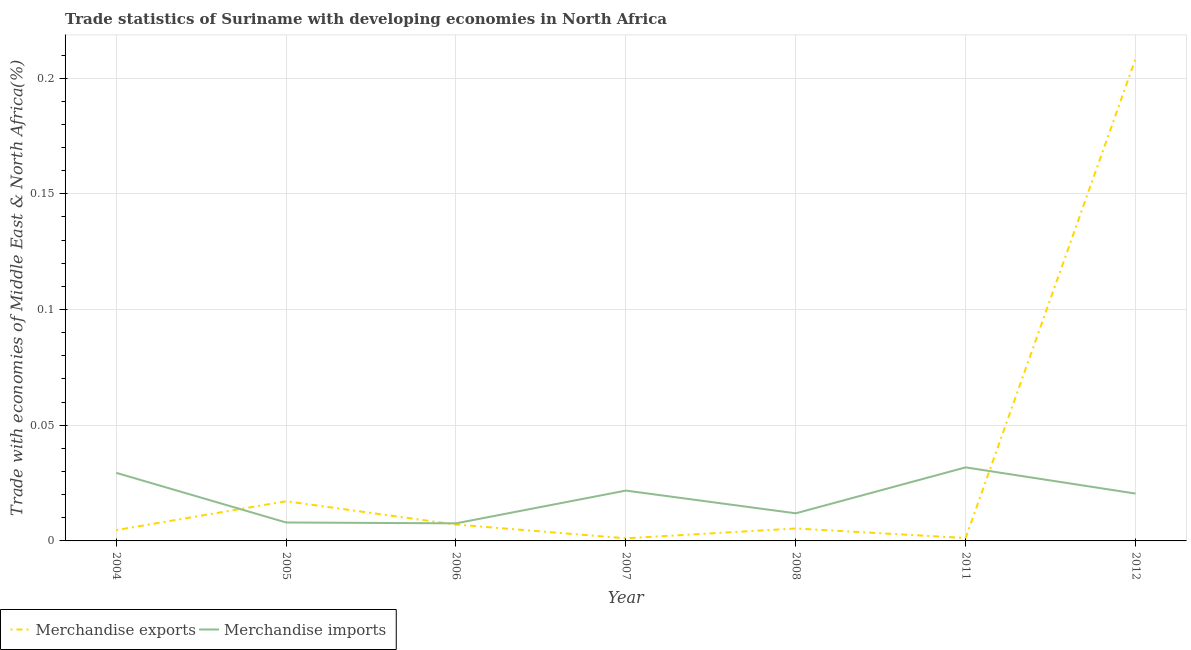How many different coloured lines are there?
Your answer should be compact. 2. Does the line corresponding to merchandise exports intersect with the line corresponding to merchandise imports?
Ensure brevity in your answer.  Yes. Is the number of lines equal to the number of legend labels?
Give a very brief answer. Yes. What is the merchandise imports in 2008?
Your answer should be very brief. 0.01. Across all years, what is the maximum merchandise imports?
Make the answer very short. 0.03. Across all years, what is the minimum merchandise exports?
Keep it short and to the point. 0. In which year was the merchandise imports minimum?
Provide a short and direct response. 2006. What is the total merchandise imports in the graph?
Your answer should be very brief. 0.13. What is the difference between the merchandise exports in 2004 and that in 2007?
Your answer should be very brief. 0. What is the difference between the merchandise imports in 2011 and the merchandise exports in 2008?
Your answer should be compact. 0.03. What is the average merchandise exports per year?
Provide a short and direct response. 0.04. In the year 2004, what is the difference between the merchandise exports and merchandise imports?
Provide a succinct answer. -0.02. What is the ratio of the merchandise exports in 2005 to that in 2008?
Your answer should be compact. 3.19. What is the difference between the highest and the second highest merchandise exports?
Give a very brief answer. 0.19. What is the difference between the highest and the lowest merchandise imports?
Provide a succinct answer. 0.02. Is the sum of the merchandise exports in 2005 and 2012 greater than the maximum merchandise imports across all years?
Offer a very short reply. Yes. Does the merchandise imports monotonically increase over the years?
Give a very brief answer. No. Is the merchandise imports strictly greater than the merchandise exports over the years?
Offer a very short reply. No. Is the merchandise imports strictly less than the merchandise exports over the years?
Give a very brief answer. No. How many lines are there?
Make the answer very short. 2. Are the values on the major ticks of Y-axis written in scientific E-notation?
Make the answer very short. No. Does the graph contain any zero values?
Your response must be concise. No. Where does the legend appear in the graph?
Give a very brief answer. Bottom left. What is the title of the graph?
Provide a short and direct response. Trade statistics of Suriname with developing economies in North Africa. Does "Long-term debt" appear as one of the legend labels in the graph?
Ensure brevity in your answer.  No. What is the label or title of the Y-axis?
Ensure brevity in your answer.  Trade with economies of Middle East & North Africa(%). What is the Trade with economies of Middle East & North Africa(%) of Merchandise exports in 2004?
Give a very brief answer. 0. What is the Trade with economies of Middle East & North Africa(%) in Merchandise imports in 2004?
Your answer should be very brief. 0.03. What is the Trade with economies of Middle East & North Africa(%) in Merchandise exports in 2005?
Offer a very short reply. 0.02. What is the Trade with economies of Middle East & North Africa(%) in Merchandise imports in 2005?
Your answer should be very brief. 0.01. What is the Trade with economies of Middle East & North Africa(%) in Merchandise exports in 2006?
Your answer should be very brief. 0.01. What is the Trade with economies of Middle East & North Africa(%) in Merchandise imports in 2006?
Give a very brief answer. 0.01. What is the Trade with economies of Middle East & North Africa(%) of Merchandise exports in 2007?
Your answer should be compact. 0. What is the Trade with economies of Middle East & North Africa(%) of Merchandise imports in 2007?
Your answer should be very brief. 0.02. What is the Trade with economies of Middle East & North Africa(%) in Merchandise exports in 2008?
Offer a terse response. 0.01. What is the Trade with economies of Middle East & North Africa(%) of Merchandise imports in 2008?
Your answer should be compact. 0.01. What is the Trade with economies of Middle East & North Africa(%) in Merchandise exports in 2011?
Keep it short and to the point. 0. What is the Trade with economies of Middle East & North Africa(%) of Merchandise imports in 2011?
Ensure brevity in your answer.  0.03. What is the Trade with economies of Middle East & North Africa(%) of Merchandise exports in 2012?
Your response must be concise. 0.21. What is the Trade with economies of Middle East & North Africa(%) in Merchandise imports in 2012?
Make the answer very short. 0.02. Across all years, what is the maximum Trade with economies of Middle East & North Africa(%) in Merchandise exports?
Offer a very short reply. 0.21. Across all years, what is the maximum Trade with economies of Middle East & North Africa(%) in Merchandise imports?
Give a very brief answer. 0.03. Across all years, what is the minimum Trade with economies of Middle East & North Africa(%) in Merchandise exports?
Give a very brief answer. 0. Across all years, what is the minimum Trade with economies of Middle East & North Africa(%) in Merchandise imports?
Your response must be concise. 0.01. What is the total Trade with economies of Middle East & North Africa(%) of Merchandise exports in the graph?
Your answer should be very brief. 0.24. What is the total Trade with economies of Middle East & North Africa(%) in Merchandise imports in the graph?
Your answer should be very brief. 0.13. What is the difference between the Trade with economies of Middle East & North Africa(%) in Merchandise exports in 2004 and that in 2005?
Offer a very short reply. -0.01. What is the difference between the Trade with economies of Middle East & North Africa(%) of Merchandise imports in 2004 and that in 2005?
Your response must be concise. 0.02. What is the difference between the Trade with economies of Middle East & North Africa(%) in Merchandise exports in 2004 and that in 2006?
Your answer should be very brief. -0. What is the difference between the Trade with economies of Middle East & North Africa(%) in Merchandise imports in 2004 and that in 2006?
Offer a very short reply. 0.02. What is the difference between the Trade with economies of Middle East & North Africa(%) of Merchandise exports in 2004 and that in 2007?
Your response must be concise. 0. What is the difference between the Trade with economies of Middle East & North Africa(%) in Merchandise imports in 2004 and that in 2007?
Ensure brevity in your answer.  0.01. What is the difference between the Trade with economies of Middle East & North Africa(%) in Merchandise exports in 2004 and that in 2008?
Give a very brief answer. -0. What is the difference between the Trade with economies of Middle East & North Africa(%) in Merchandise imports in 2004 and that in 2008?
Offer a very short reply. 0.02. What is the difference between the Trade with economies of Middle East & North Africa(%) of Merchandise exports in 2004 and that in 2011?
Keep it short and to the point. 0. What is the difference between the Trade with economies of Middle East & North Africa(%) of Merchandise imports in 2004 and that in 2011?
Provide a succinct answer. -0. What is the difference between the Trade with economies of Middle East & North Africa(%) of Merchandise exports in 2004 and that in 2012?
Ensure brevity in your answer.  -0.2. What is the difference between the Trade with economies of Middle East & North Africa(%) of Merchandise imports in 2004 and that in 2012?
Offer a very short reply. 0.01. What is the difference between the Trade with economies of Middle East & North Africa(%) of Merchandise exports in 2005 and that in 2006?
Your response must be concise. 0.01. What is the difference between the Trade with economies of Middle East & North Africa(%) of Merchandise exports in 2005 and that in 2007?
Provide a succinct answer. 0.02. What is the difference between the Trade with economies of Middle East & North Africa(%) in Merchandise imports in 2005 and that in 2007?
Provide a succinct answer. -0.01. What is the difference between the Trade with economies of Middle East & North Africa(%) in Merchandise exports in 2005 and that in 2008?
Offer a very short reply. 0.01. What is the difference between the Trade with economies of Middle East & North Africa(%) in Merchandise imports in 2005 and that in 2008?
Give a very brief answer. -0. What is the difference between the Trade with economies of Middle East & North Africa(%) in Merchandise exports in 2005 and that in 2011?
Your response must be concise. 0.02. What is the difference between the Trade with economies of Middle East & North Africa(%) of Merchandise imports in 2005 and that in 2011?
Keep it short and to the point. -0.02. What is the difference between the Trade with economies of Middle East & North Africa(%) of Merchandise exports in 2005 and that in 2012?
Provide a succinct answer. -0.19. What is the difference between the Trade with economies of Middle East & North Africa(%) in Merchandise imports in 2005 and that in 2012?
Ensure brevity in your answer.  -0.01. What is the difference between the Trade with economies of Middle East & North Africa(%) of Merchandise exports in 2006 and that in 2007?
Ensure brevity in your answer.  0.01. What is the difference between the Trade with economies of Middle East & North Africa(%) in Merchandise imports in 2006 and that in 2007?
Offer a terse response. -0.01. What is the difference between the Trade with economies of Middle East & North Africa(%) in Merchandise exports in 2006 and that in 2008?
Provide a succinct answer. 0. What is the difference between the Trade with economies of Middle East & North Africa(%) in Merchandise imports in 2006 and that in 2008?
Make the answer very short. -0. What is the difference between the Trade with economies of Middle East & North Africa(%) in Merchandise exports in 2006 and that in 2011?
Make the answer very short. 0.01. What is the difference between the Trade with economies of Middle East & North Africa(%) of Merchandise imports in 2006 and that in 2011?
Your answer should be very brief. -0.02. What is the difference between the Trade with economies of Middle East & North Africa(%) in Merchandise exports in 2006 and that in 2012?
Your response must be concise. -0.2. What is the difference between the Trade with economies of Middle East & North Africa(%) in Merchandise imports in 2006 and that in 2012?
Offer a very short reply. -0.01. What is the difference between the Trade with economies of Middle East & North Africa(%) in Merchandise exports in 2007 and that in 2008?
Your answer should be compact. -0. What is the difference between the Trade with economies of Middle East & North Africa(%) in Merchandise imports in 2007 and that in 2008?
Give a very brief answer. 0.01. What is the difference between the Trade with economies of Middle East & North Africa(%) in Merchandise exports in 2007 and that in 2011?
Make the answer very short. -0. What is the difference between the Trade with economies of Middle East & North Africa(%) of Merchandise imports in 2007 and that in 2011?
Make the answer very short. -0.01. What is the difference between the Trade with economies of Middle East & North Africa(%) in Merchandise exports in 2007 and that in 2012?
Your response must be concise. -0.21. What is the difference between the Trade with economies of Middle East & North Africa(%) of Merchandise imports in 2007 and that in 2012?
Ensure brevity in your answer.  0. What is the difference between the Trade with economies of Middle East & North Africa(%) of Merchandise exports in 2008 and that in 2011?
Your answer should be very brief. 0. What is the difference between the Trade with economies of Middle East & North Africa(%) in Merchandise imports in 2008 and that in 2011?
Make the answer very short. -0.02. What is the difference between the Trade with economies of Middle East & North Africa(%) in Merchandise exports in 2008 and that in 2012?
Your answer should be very brief. -0.2. What is the difference between the Trade with economies of Middle East & North Africa(%) in Merchandise imports in 2008 and that in 2012?
Make the answer very short. -0.01. What is the difference between the Trade with economies of Middle East & North Africa(%) in Merchandise exports in 2011 and that in 2012?
Your response must be concise. -0.21. What is the difference between the Trade with economies of Middle East & North Africa(%) in Merchandise imports in 2011 and that in 2012?
Provide a succinct answer. 0.01. What is the difference between the Trade with economies of Middle East & North Africa(%) of Merchandise exports in 2004 and the Trade with economies of Middle East & North Africa(%) of Merchandise imports in 2005?
Your answer should be compact. -0. What is the difference between the Trade with economies of Middle East & North Africa(%) in Merchandise exports in 2004 and the Trade with economies of Middle East & North Africa(%) in Merchandise imports in 2006?
Provide a succinct answer. -0. What is the difference between the Trade with economies of Middle East & North Africa(%) in Merchandise exports in 2004 and the Trade with economies of Middle East & North Africa(%) in Merchandise imports in 2007?
Give a very brief answer. -0.02. What is the difference between the Trade with economies of Middle East & North Africa(%) of Merchandise exports in 2004 and the Trade with economies of Middle East & North Africa(%) of Merchandise imports in 2008?
Keep it short and to the point. -0.01. What is the difference between the Trade with economies of Middle East & North Africa(%) in Merchandise exports in 2004 and the Trade with economies of Middle East & North Africa(%) in Merchandise imports in 2011?
Your response must be concise. -0.03. What is the difference between the Trade with economies of Middle East & North Africa(%) of Merchandise exports in 2004 and the Trade with economies of Middle East & North Africa(%) of Merchandise imports in 2012?
Offer a terse response. -0.02. What is the difference between the Trade with economies of Middle East & North Africa(%) in Merchandise exports in 2005 and the Trade with economies of Middle East & North Africa(%) in Merchandise imports in 2006?
Offer a terse response. 0.01. What is the difference between the Trade with economies of Middle East & North Africa(%) of Merchandise exports in 2005 and the Trade with economies of Middle East & North Africa(%) of Merchandise imports in 2007?
Give a very brief answer. -0. What is the difference between the Trade with economies of Middle East & North Africa(%) of Merchandise exports in 2005 and the Trade with economies of Middle East & North Africa(%) of Merchandise imports in 2008?
Your answer should be very brief. 0.01. What is the difference between the Trade with economies of Middle East & North Africa(%) in Merchandise exports in 2005 and the Trade with economies of Middle East & North Africa(%) in Merchandise imports in 2011?
Offer a very short reply. -0.01. What is the difference between the Trade with economies of Middle East & North Africa(%) in Merchandise exports in 2005 and the Trade with economies of Middle East & North Africa(%) in Merchandise imports in 2012?
Your answer should be very brief. -0. What is the difference between the Trade with economies of Middle East & North Africa(%) of Merchandise exports in 2006 and the Trade with economies of Middle East & North Africa(%) of Merchandise imports in 2007?
Your answer should be very brief. -0.01. What is the difference between the Trade with economies of Middle East & North Africa(%) in Merchandise exports in 2006 and the Trade with economies of Middle East & North Africa(%) in Merchandise imports in 2008?
Your answer should be compact. -0. What is the difference between the Trade with economies of Middle East & North Africa(%) in Merchandise exports in 2006 and the Trade with economies of Middle East & North Africa(%) in Merchandise imports in 2011?
Offer a very short reply. -0.02. What is the difference between the Trade with economies of Middle East & North Africa(%) in Merchandise exports in 2006 and the Trade with economies of Middle East & North Africa(%) in Merchandise imports in 2012?
Provide a short and direct response. -0.01. What is the difference between the Trade with economies of Middle East & North Africa(%) of Merchandise exports in 2007 and the Trade with economies of Middle East & North Africa(%) of Merchandise imports in 2008?
Offer a terse response. -0.01. What is the difference between the Trade with economies of Middle East & North Africa(%) of Merchandise exports in 2007 and the Trade with economies of Middle East & North Africa(%) of Merchandise imports in 2011?
Your response must be concise. -0.03. What is the difference between the Trade with economies of Middle East & North Africa(%) of Merchandise exports in 2007 and the Trade with economies of Middle East & North Africa(%) of Merchandise imports in 2012?
Provide a succinct answer. -0.02. What is the difference between the Trade with economies of Middle East & North Africa(%) of Merchandise exports in 2008 and the Trade with economies of Middle East & North Africa(%) of Merchandise imports in 2011?
Make the answer very short. -0.03. What is the difference between the Trade with economies of Middle East & North Africa(%) of Merchandise exports in 2008 and the Trade with economies of Middle East & North Africa(%) of Merchandise imports in 2012?
Your answer should be very brief. -0.02. What is the difference between the Trade with economies of Middle East & North Africa(%) in Merchandise exports in 2011 and the Trade with economies of Middle East & North Africa(%) in Merchandise imports in 2012?
Offer a terse response. -0.02. What is the average Trade with economies of Middle East & North Africa(%) in Merchandise exports per year?
Make the answer very short. 0.04. What is the average Trade with economies of Middle East & North Africa(%) of Merchandise imports per year?
Provide a short and direct response. 0.02. In the year 2004, what is the difference between the Trade with economies of Middle East & North Africa(%) of Merchandise exports and Trade with economies of Middle East & North Africa(%) of Merchandise imports?
Offer a very short reply. -0.02. In the year 2005, what is the difference between the Trade with economies of Middle East & North Africa(%) of Merchandise exports and Trade with economies of Middle East & North Africa(%) of Merchandise imports?
Give a very brief answer. 0.01. In the year 2006, what is the difference between the Trade with economies of Middle East & North Africa(%) of Merchandise exports and Trade with economies of Middle East & North Africa(%) of Merchandise imports?
Offer a terse response. -0. In the year 2007, what is the difference between the Trade with economies of Middle East & North Africa(%) in Merchandise exports and Trade with economies of Middle East & North Africa(%) in Merchandise imports?
Provide a succinct answer. -0.02. In the year 2008, what is the difference between the Trade with economies of Middle East & North Africa(%) in Merchandise exports and Trade with economies of Middle East & North Africa(%) in Merchandise imports?
Give a very brief answer. -0.01. In the year 2011, what is the difference between the Trade with economies of Middle East & North Africa(%) in Merchandise exports and Trade with economies of Middle East & North Africa(%) in Merchandise imports?
Ensure brevity in your answer.  -0.03. In the year 2012, what is the difference between the Trade with economies of Middle East & North Africa(%) of Merchandise exports and Trade with economies of Middle East & North Africa(%) of Merchandise imports?
Ensure brevity in your answer.  0.19. What is the ratio of the Trade with economies of Middle East & North Africa(%) of Merchandise exports in 2004 to that in 2005?
Your answer should be very brief. 0.27. What is the ratio of the Trade with economies of Middle East & North Africa(%) of Merchandise imports in 2004 to that in 2005?
Your answer should be compact. 3.69. What is the ratio of the Trade with economies of Middle East & North Africa(%) in Merchandise exports in 2004 to that in 2006?
Provide a succinct answer. 0.66. What is the ratio of the Trade with economies of Middle East & North Africa(%) of Merchandise imports in 2004 to that in 2006?
Provide a short and direct response. 3.87. What is the ratio of the Trade with economies of Middle East & North Africa(%) of Merchandise exports in 2004 to that in 2007?
Provide a succinct answer. 4.11. What is the ratio of the Trade with economies of Middle East & North Africa(%) in Merchandise imports in 2004 to that in 2007?
Provide a short and direct response. 1.35. What is the ratio of the Trade with economies of Middle East & North Africa(%) in Merchandise exports in 2004 to that in 2008?
Your response must be concise. 0.87. What is the ratio of the Trade with economies of Middle East & North Africa(%) of Merchandise imports in 2004 to that in 2008?
Your response must be concise. 2.47. What is the ratio of the Trade with economies of Middle East & North Africa(%) in Merchandise exports in 2004 to that in 2011?
Give a very brief answer. 3.74. What is the ratio of the Trade with economies of Middle East & North Africa(%) of Merchandise imports in 2004 to that in 2011?
Keep it short and to the point. 0.93. What is the ratio of the Trade with economies of Middle East & North Africa(%) in Merchandise exports in 2004 to that in 2012?
Ensure brevity in your answer.  0.02. What is the ratio of the Trade with economies of Middle East & North Africa(%) in Merchandise imports in 2004 to that in 2012?
Give a very brief answer. 1.44. What is the ratio of the Trade with economies of Middle East & North Africa(%) in Merchandise exports in 2005 to that in 2006?
Ensure brevity in your answer.  2.43. What is the ratio of the Trade with economies of Middle East & North Africa(%) in Merchandise imports in 2005 to that in 2006?
Ensure brevity in your answer.  1.05. What is the ratio of the Trade with economies of Middle East & North Africa(%) in Merchandise exports in 2005 to that in 2007?
Provide a short and direct response. 15.05. What is the ratio of the Trade with economies of Middle East & North Africa(%) of Merchandise imports in 2005 to that in 2007?
Your answer should be compact. 0.37. What is the ratio of the Trade with economies of Middle East & North Africa(%) of Merchandise exports in 2005 to that in 2008?
Provide a succinct answer. 3.19. What is the ratio of the Trade with economies of Middle East & North Africa(%) of Merchandise imports in 2005 to that in 2008?
Your response must be concise. 0.67. What is the ratio of the Trade with economies of Middle East & North Africa(%) in Merchandise exports in 2005 to that in 2011?
Your response must be concise. 13.7. What is the ratio of the Trade with economies of Middle East & North Africa(%) of Merchandise imports in 2005 to that in 2011?
Your answer should be compact. 0.25. What is the ratio of the Trade with economies of Middle East & North Africa(%) of Merchandise exports in 2005 to that in 2012?
Offer a very short reply. 0.08. What is the ratio of the Trade with economies of Middle East & North Africa(%) in Merchandise imports in 2005 to that in 2012?
Offer a terse response. 0.39. What is the ratio of the Trade with economies of Middle East & North Africa(%) of Merchandise exports in 2006 to that in 2007?
Provide a succinct answer. 6.2. What is the ratio of the Trade with economies of Middle East & North Africa(%) of Merchandise imports in 2006 to that in 2007?
Provide a succinct answer. 0.35. What is the ratio of the Trade with economies of Middle East & North Africa(%) in Merchandise exports in 2006 to that in 2008?
Provide a succinct answer. 1.32. What is the ratio of the Trade with economies of Middle East & North Africa(%) of Merchandise imports in 2006 to that in 2008?
Provide a short and direct response. 0.64. What is the ratio of the Trade with economies of Middle East & North Africa(%) of Merchandise exports in 2006 to that in 2011?
Ensure brevity in your answer.  5.65. What is the ratio of the Trade with economies of Middle East & North Africa(%) in Merchandise imports in 2006 to that in 2011?
Keep it short and to the point. 0.24. What is the ratio of the Trade with economies of Middle East & North Africa(%) of Merchandise exports in 2006 to that in 2012?
Offer a terse response. 0.03. What is the ratio of the Trade with economies of Middle East & North Africa(%) of Merchandise imports in 2006 to that in 2012?
Provide a succinct answer. 0.37. What is the ratio of the Trade with economies of Middle East & North Africa(%) in Merchandise exports in 2007 to that in 2008?
Provide a short and direct response. 0.21. What is the ratio of the Trade with economies of Middle East & North Africa(%) of Merchandise imports in 2007 to that in 2008?
Offer a very short reply. 1.82. What is the ratio of the Trade with economies of Middle East & North Africa(%) of Merchandise exports in 2007 to that in 2011?
Keep it short and to the point. 0.91. What is the ratio of the Trade with economies of Middle East & North Africa(%) of Merchandise imports in 2007 to that in 2011?
Offer a very short reply. 0.68. What is the ratio of the Trade with economies of Middle East & North Africa(%) in Merchandise exports in 2007 to that in 2012?
Your answer should be very brief. 0.01. What is the ratio of the Trade with economies of Middle East & North Africa(%) of Merchandise imports in 2007 to that in 2012?
Offer a terse response. 1.06. What is the ratio of the Trade with economies of Middle East & North Africa(%) of Merchandise exports in 2008 to that in 2011?
Your response must be concise. 4.3. What is the ratio of the Trade with economies of Middle East & North Africa(%) of Merchandise imports in 2008 to that in 2011?
Make the answer very short. 0.38. What is the ratio of the Trade with economies of Middle East & North Africa(%) in Merchandise exports in 2008 to that in 2012?
Offer a terse response. 0.03. What is the ratio of the Trade with economies of Middle East & North Africa(%) of Merchandise imports in 2008 to that in 2012?
Offer a very short reply. 0.58. What is the ratio of the Trade with economies of Middle East & North Africa(%) of Merchandise exports in 2011 to that in 2012?
Your response must be concise. 0.01. What is the ratio of the Trade with economies of Middle East & North Africa(%) of Merchandise imports in 2011 to that in 2012?
Keep it short and to the point. 1.55. What is the difference between the highest and the second highest Trade with economies of Middle East & North Africa(%) in Merchandise exports?
Provide a succinct answer. 0.19. What is the difference between the highest and the second highest Trade with economies of Middle East & North Africa(%) of Merchandise imports?
Make the answer very short. 0. What is the difference between the highest and the lowest Trade with economies of Middle East & North Africa(%) in Merchandise exports?
Keep it short and to the point. 0.21. What is the difference between the highest and the lowest Trade with economies of Middle East & North Africa(%) of Merchandise imports?
Keep it short and to the point. 0.02. 